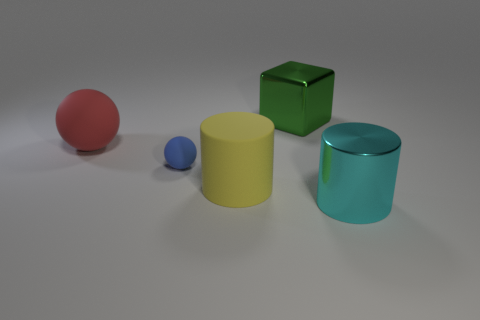The object left of the matte sphere that is in front of the big thing that is left of the yellow matte object is made of what material?
Provide a succinct answer. Rubber. How many metal things are red objects or small blue spheres?
Keep it short and to the point. 0. Is the big metallic cylinder the same color as the tiny rubber thing?
Keep it short and to the point. No. Is there any other thing that is made of the same material as the tiny blue sphere?
Offer a terse response. Yes. What number of things are green metallic cubes or objects that are in front of the cube?
Provide a short and direct response. 5. Do the metallic object that is in front of the cube and the blue rubber sphere have the same size?
Keep it short and to the point. No. What number of other things are there of the same shape as the cyan metal thing?
Make the answer very short. 1. How many purple objects are large metal objects or big balls?
Provide a succinct answer. 0. Do the metallic object in front of the large yellow object and the big rubber cylinder have the same color?
Offer a very short reply. No. The big yellow object that is made of the same material as the red sphere is what shape?
Your answer should be compact. Cylinder. 